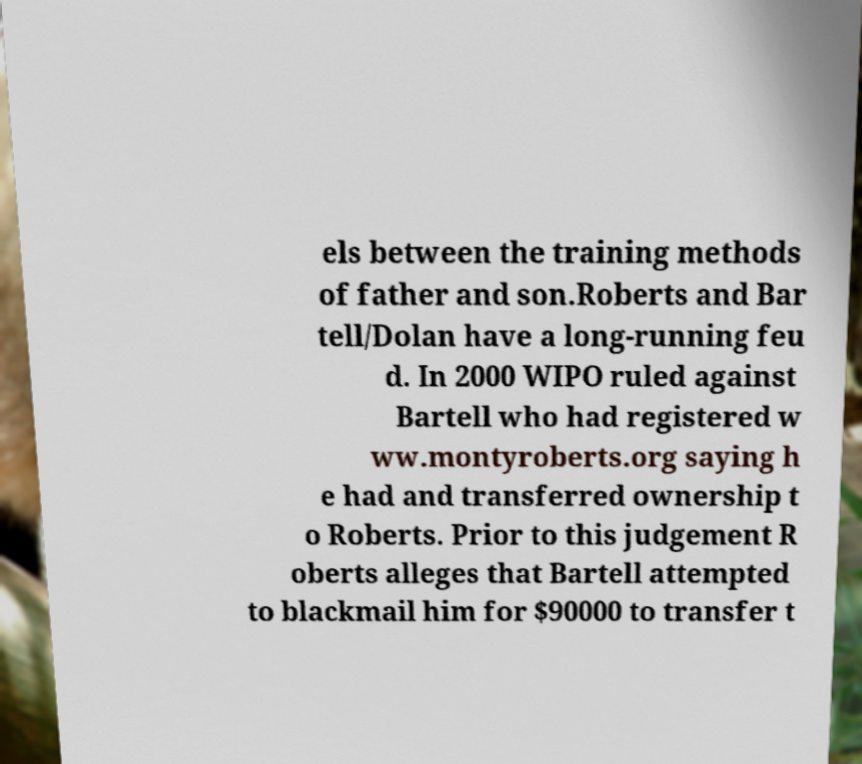Could you extract and type out the text from this image? els between the training methods of father and son.Roberts and Bar tell/Dolan have a long-running feu d. In 2000 WIPO ruled against Bartell who had registered w ww.montyroberts.org saying h e had and transferred ownership t o Roberts. Prior to this judgement R oberts alleges that Bartell attempted to blackmail him for $90000 to transfer t 